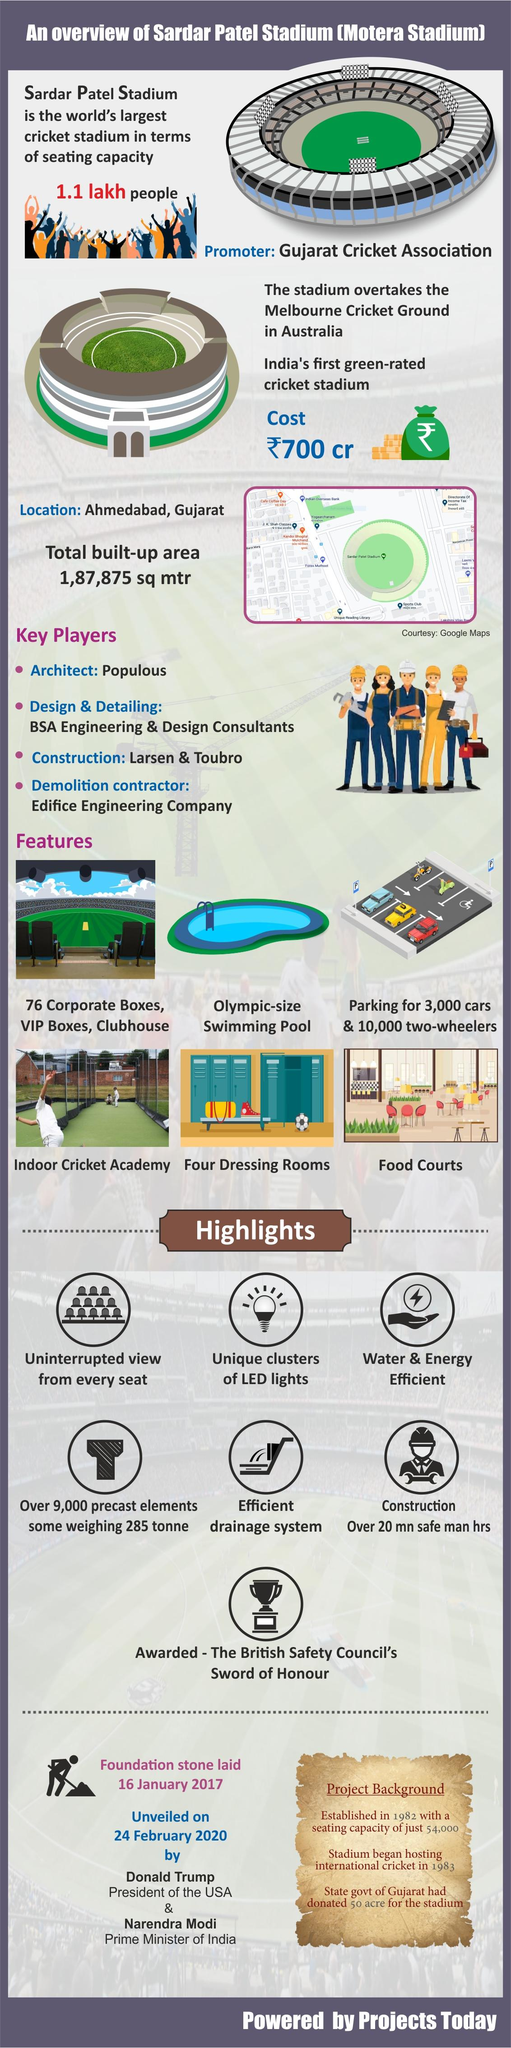List a handful of essential elements in this visual. The Sardar Patel Stadium is capable of accommodating up to 1.1 lakh people. The cost of construction for Sardar Patel Stadium is approximately ₹700 crores. 